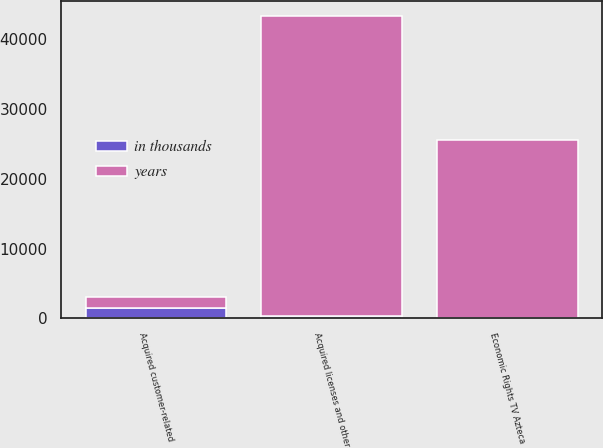<chart> <loc_0><loc_0><loc_500><loc_500><stacked_bar_chart><ecel><fcel>Acquired customer-related<fcel>Acquired licenses and other<fcel>Economic Rights TV Azteca<nl><fcel>in thousands<fcel>1520<fcel>320<fcel>70<nl><fcel>years<fcel>1520<fcel>43012<fcel>25522<nl></chart> 